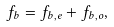<formula> <loc_0><loc_0><loc_500><loc_500>f _ { b } = f _ { b , e } + f _ { b , o } ,</formula> 